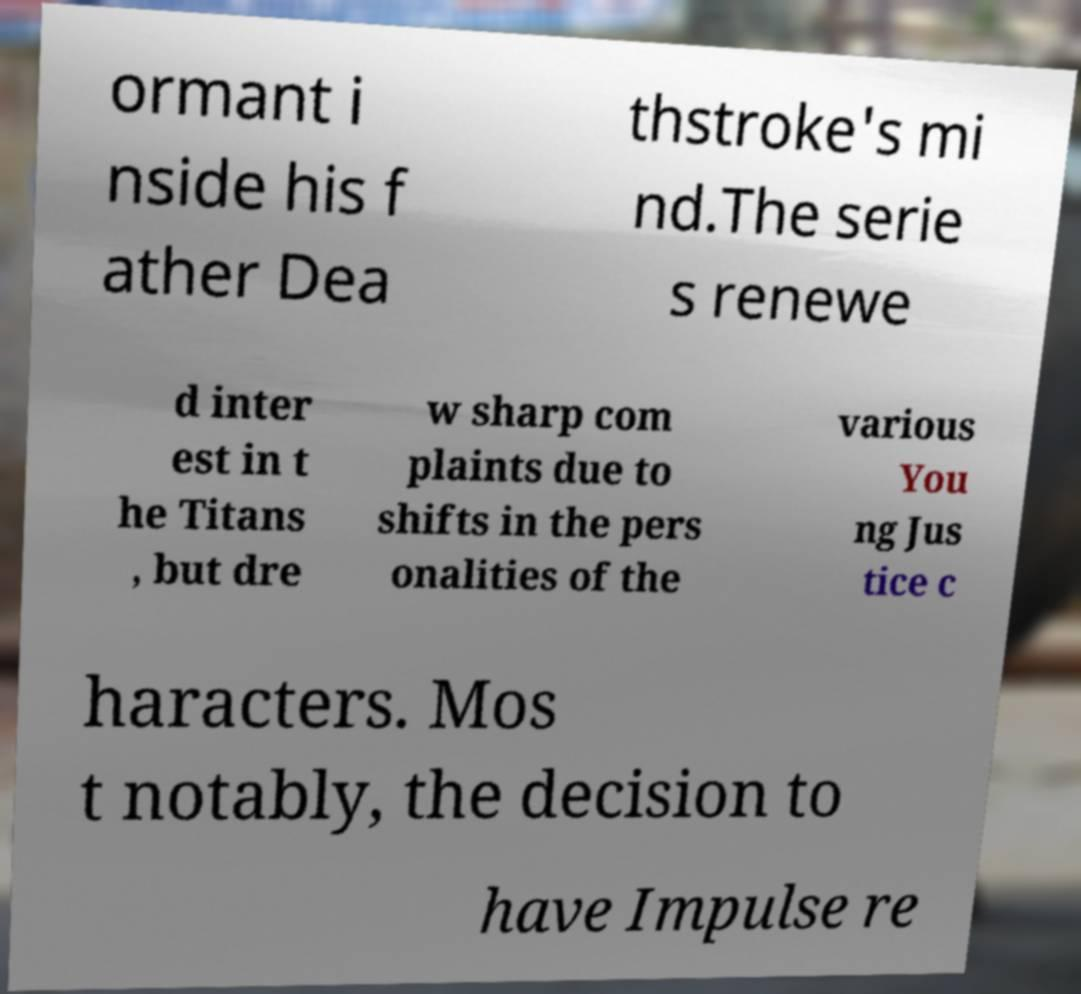Can you read and provide the text displayed in the image?This photo seems to have some interesting text. Can you extract and type it out for me? ormant i nside his f ather Dea thstroke's mi nd.The serie s renewe d inter est in t he Titans , but dre w sharp com plaints due to shifts in the pers onalities of the various You ng Jus tice c haracters. Mos t notably, the decision to have Impulse re 